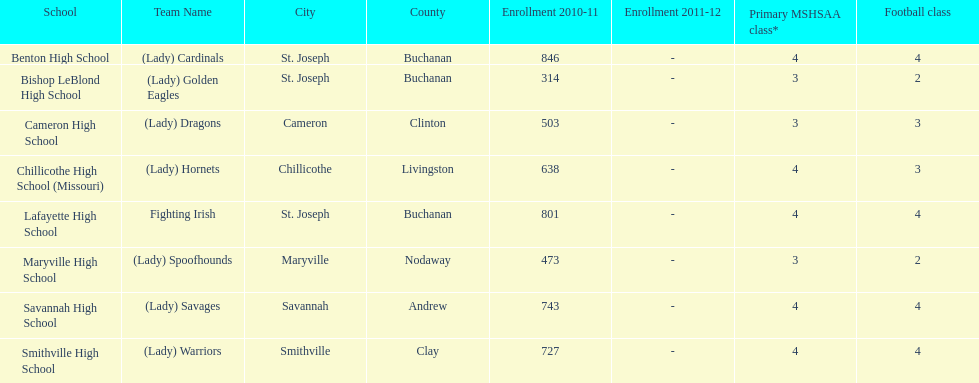How many of the schools had at least 500 students enrolled in the 2010-2011 and 2011-2012 season? 6. 